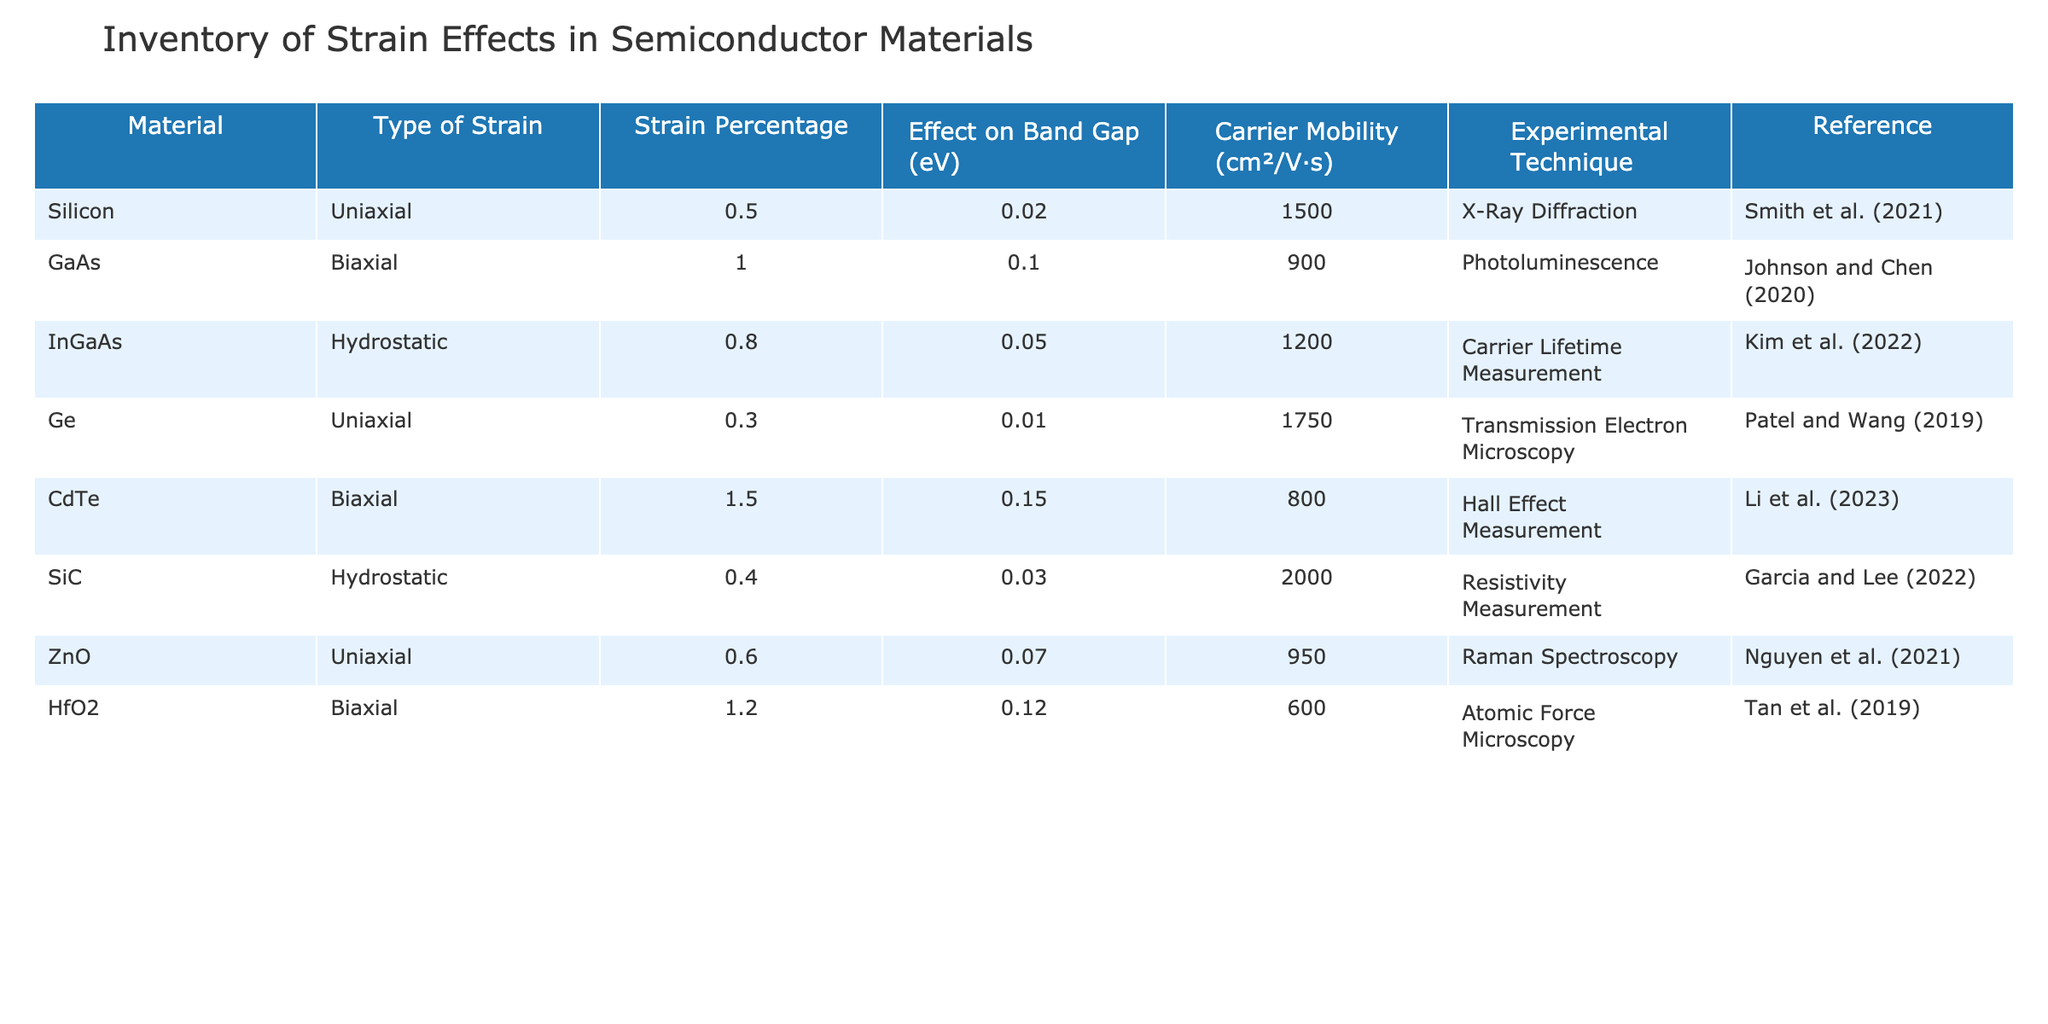What is the effect on the band gap of GaAs when a biaxial strain of 1.0% is applied? According to the table, the effect on the band gap for GaAs under a biaxial strain of 1.0% is recorded as 0.1 eV.
Answer: 0.1 eV Which material has the highest carrier mobility? By reviewing the Carrier Mobility column, Silicon has the highest mobility at 1500 cm²/V·s.
Answer: Silicon Is the effect on the band gap for InGaAs negative or positive when hydrostatic strain is applied? The table indicates an increase in band gap of 0.05 eV for InGaAs, which is a positive effect.
Answer: Positive What is the average strain percentage across all materials listed? The strain percentages are 0.5, 1.0, 0.8, 0.3, 1.5, 0.4, 0.6, and 1.2, which sums to 6.3. Dividing this sum by the number of materials (8) gives an average of 0.7875%.
Answer: 0.7875% Does CdTe show a higher effect on band gap than ZnO with their respective strains? CdTe has an effect of 0.15 eV while ZnO has 0.07 eV. Since 0.15 is greater than 0.07, the statement is true.
Answer: Yes Which experimental technique was used for measuring carrier lifetime in InGaAs? The table specifies that Carrier Lifetime Measurement was the experimental technique employed for InGaAs.
Answer: Carrier Lifetime Measurement Are materials with uniaxial strain more likely to have a greater effect on band gap compared to those with biaxial strain? The effects on the band gap for uniaxial strains (0.02 for Silicon, 0.01 for Ge, 0.07 for ZnO) average to 0.03 eV. Biaxial strains (0.1 for GaAs, 0.15 for CdTe, 0.12 for HfO2) average to 0.12 eV, which is higher, thus the assumption is false.
Answer: No What is the effect on carrier mobility when a hydrostatic strain of 0.4% is applied to SiC? According to the data, the carrier mobility under hydrostatic strain for SiC is 2000 cm²/V·s, reflecting no effect on mobility as the value is stated directly.
Answer: 2000 cm²/V·s 